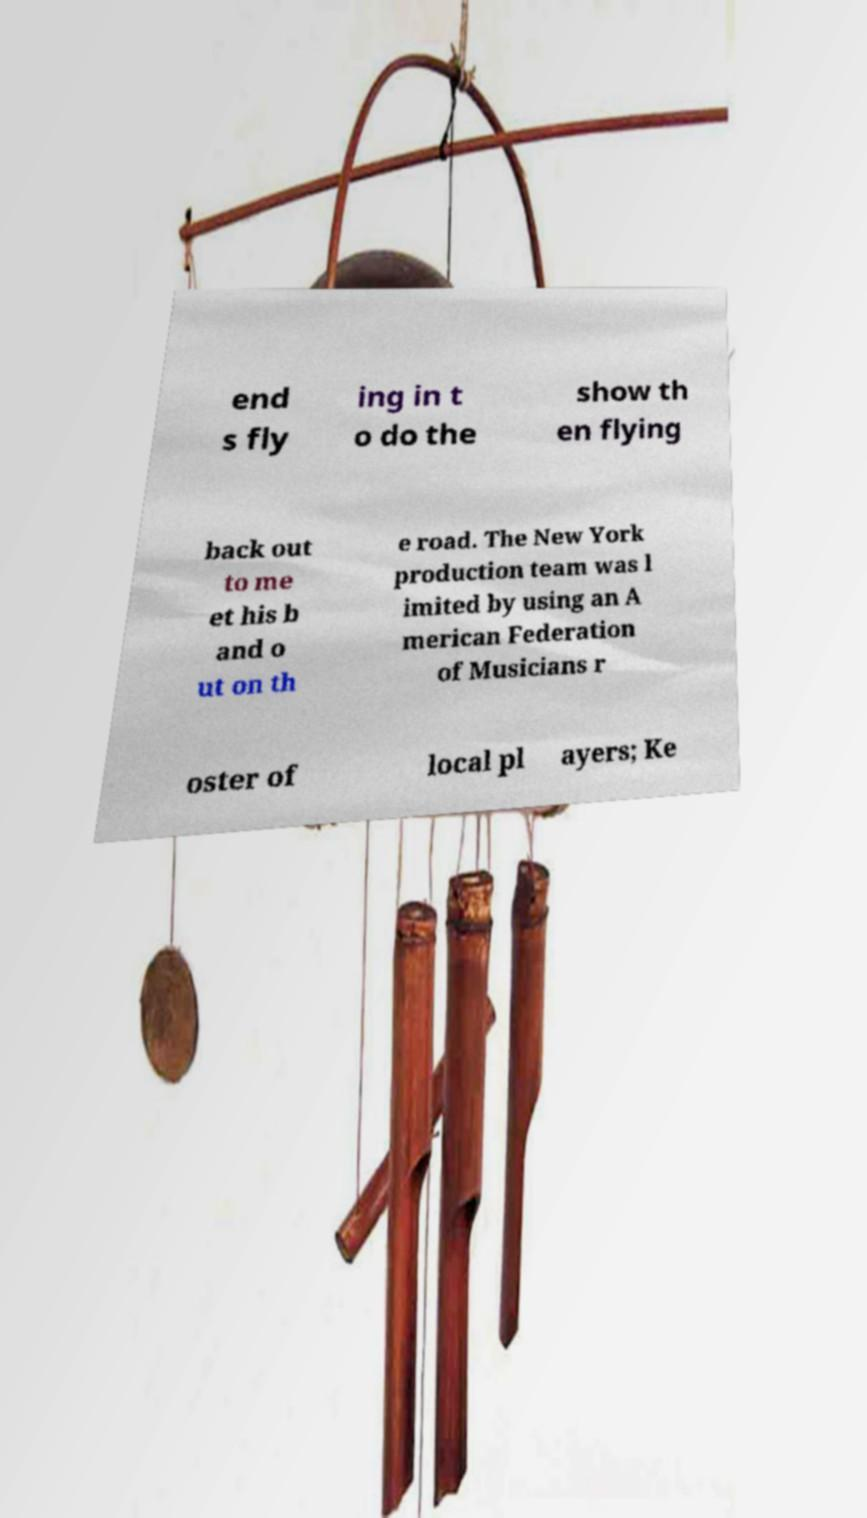What messages or text are displayed in this image? I need them in a readable, typed format. end s fly ing in t o do the show th en flying back out to me et his b and o ut on th e road. The New York production team was l imited by using an A merican Federation of Musicians r oster of local pl ayers; Ke 